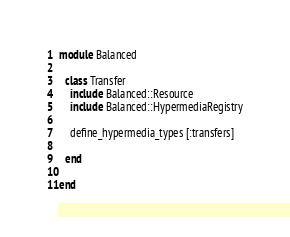<code> <loc_0><loc_0><loc_500><loc_500><_Ruby_>module Balanced

  class Transfer
    include Balanced::Resource
    include Balanced::HypermediaRegistry

    define_hypermedia_types [:transfers]

  end

end
</code> 